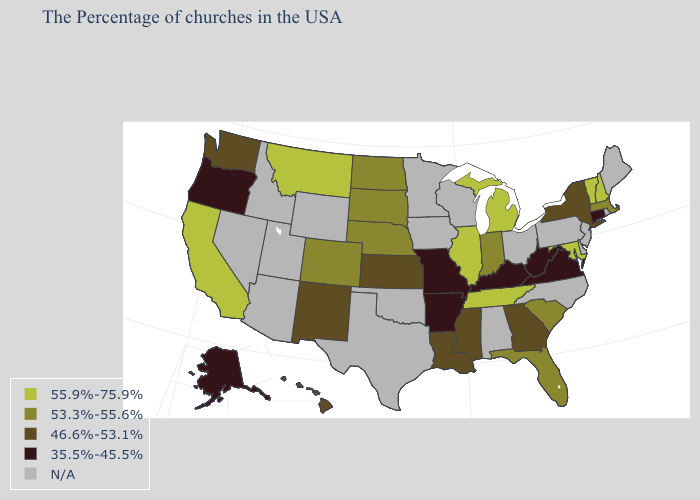What is the value of Mississippi?
Quick response, please. 46.6%-53.1%. Name the states that have a value in the range 46.6%-53.1%?
Answer briefly. New York, Georgia, Mississippi, Louisiana, Kansas, New Mexico, Washington, Hawaii. What is the highest value in the West ?
Keep it brief. 55.9%-75.9%. What is the highest value in the West ?
Answer briefly. 55.9%-75.9%. Name the states that have a value in the range 35.5%-45.5%?
Write a very short answer. Connecticut, Virginia, West Virginia, Kentucky, Missouri, Arkansas, Oregon, Alaska. What is the highest value in the USA?
Concise answer only. 55.9%-75.9%. Does Virginia have the lowest value in the USA?
Short answer required. Yes. What is the lowest value in the USA?
Short answer required. 35.5%-45.5%. What is the lowest value in the USA?
Be succinct. 35.5%-45.5%. Name the states that have a value in the range 55.9%-75.9%?
Give a very brief answer. New Hampshire, Vermont, Maryland, Michigan, Tennessee, Illinois, Montana, California. Does the first symbol in the legend represent the smallest category?
Answer briefly. No. How many symbols are there in the legend?
Be succinct. 5. Which states have the lowest value in the South?
Quick response, please. Virginia, West Virginia, Kentucky, Arkansas. Is the legend a continuous bar?
Give a very brief answer. No. What is the lowest value in states that border Colorado?
Concise answer only. 46.6%-53.1%. 